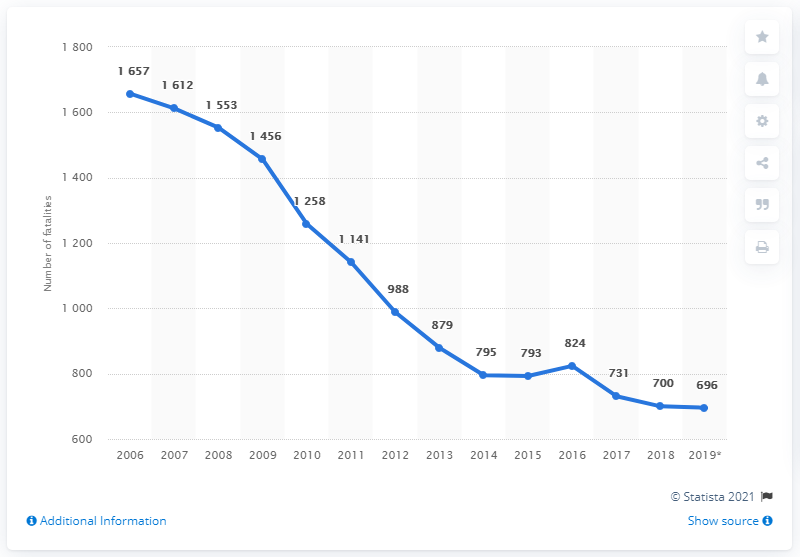Outline some significant characteristics in this image. The highest number of road fatalities occurred in 2006. There were 824 road fatalities between 2015 and 2016. 